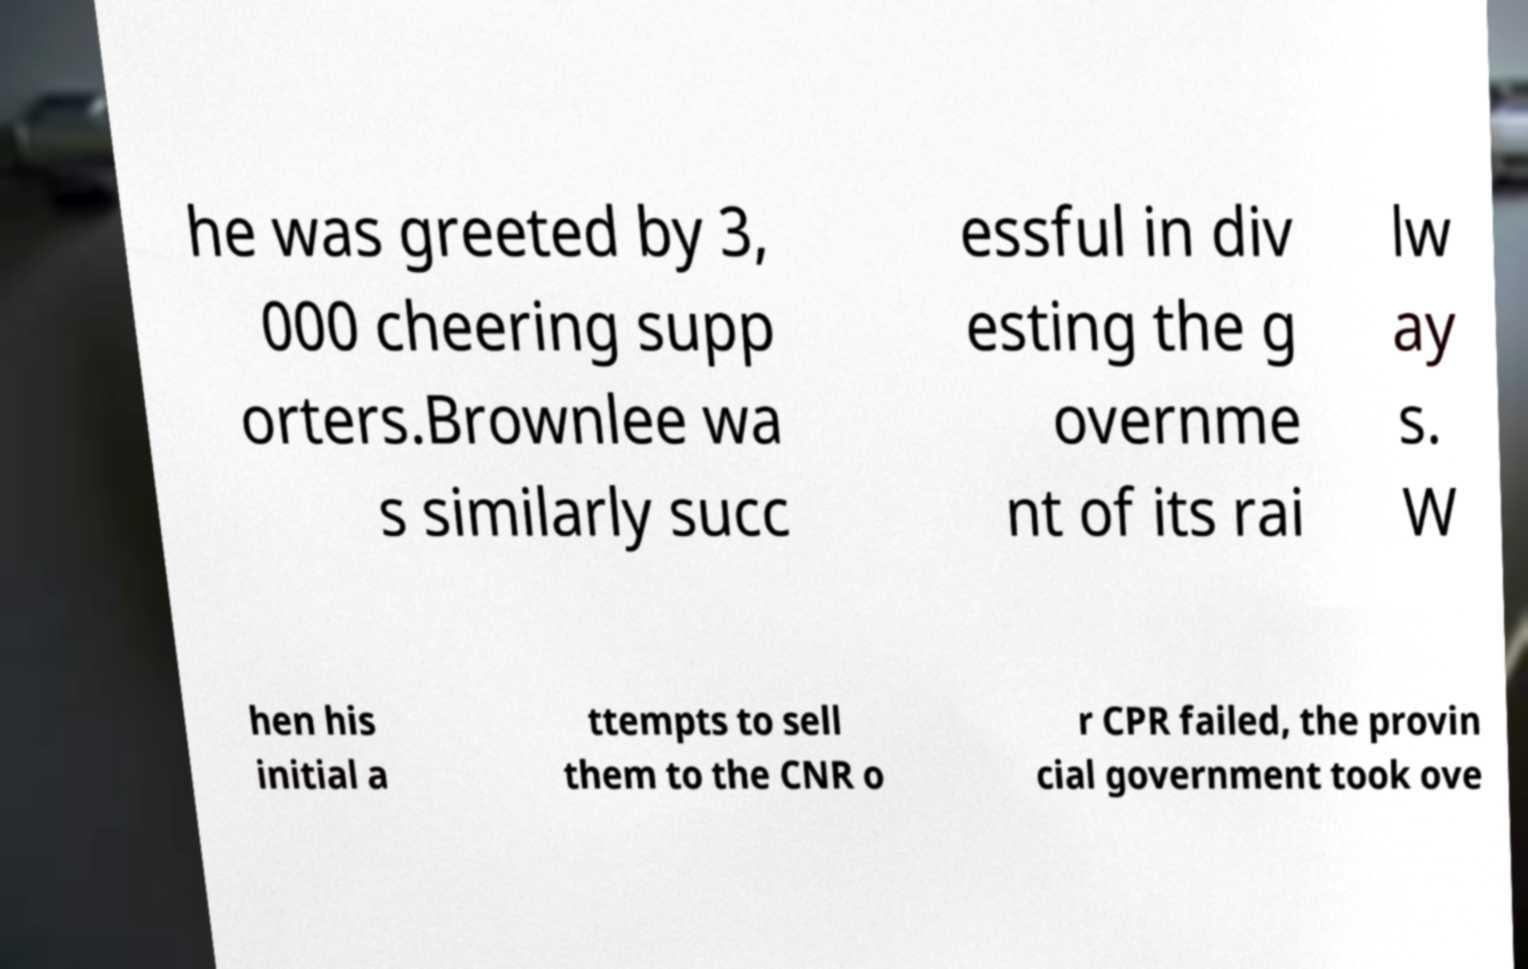There's text embedded in this image that I need extracted. Can you transcribe it verbatim? he was greeted by 3, 000 cheering supp orters.Brownlee wa s similarly succ essful in div esting the g overnme nt of its rai lw ay s. W hen his initial a ttempts to sell them to the CNR o r CPR failed, the provin cial government took ove 